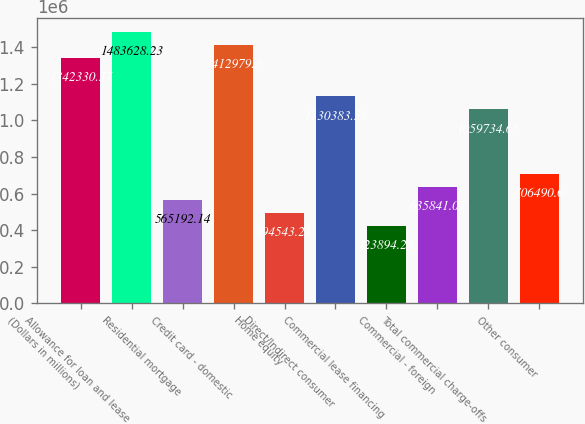Convert chart. <chart><loc_0><loc_0><loc_500><loc_500><bar_chart><fcel>(Dollars in millions)<fcel>Allowance for loan and lease<fcel>Residential mortgage<fcel>Credit card - domestic<fcel>Home equity<fcel>Direct/Indirect consumer<fcel>Commercial lease financing<fcel>Commercial - foreign<fcel>Total commercial charge-offs<fcel>Other consumer<nl><fcel>1.34233e+06<fcel>1.48363e+06<fcel>565192<fcel>1.41298e+06<fcel>494543<fcel>1.13038e+06<fcel>423894<fcel>635841<fcel>1.05973e+06<fcel>706490<nl></chart> 